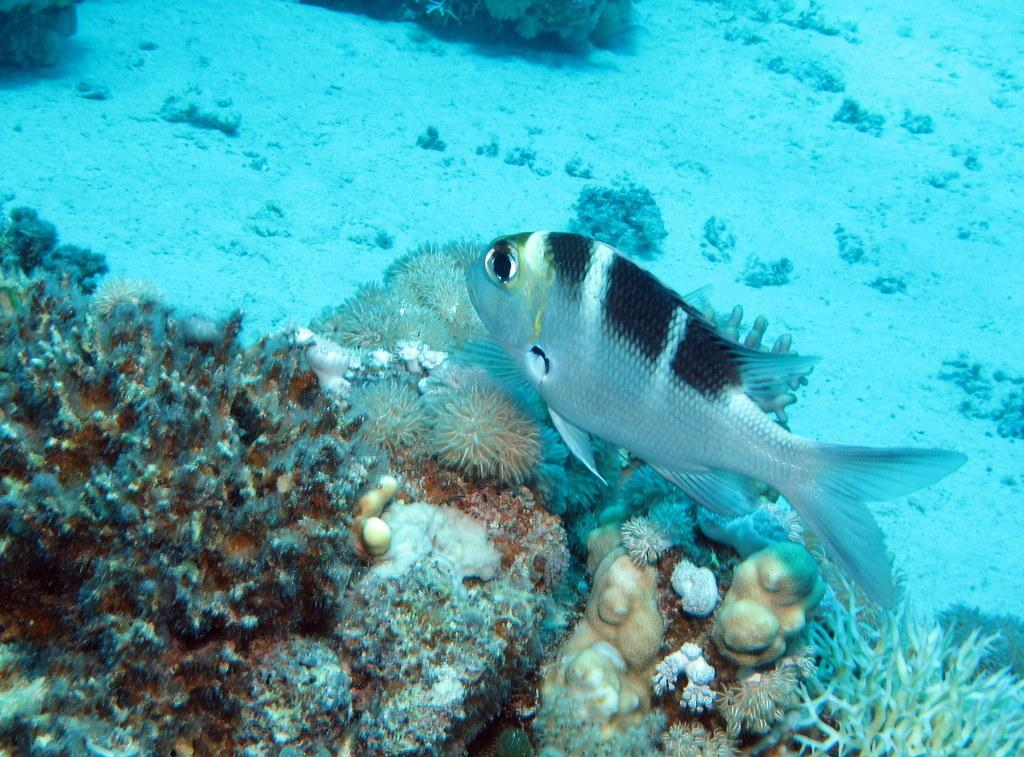What is the setting of the image? The image is taken underwater. What can be seen at the center of the image? There is a fish at the center of the image. Is there a badge visible on the fish in the image? There is no badge present on the fish in the image. Can you see a scarecrow in the underwater scene? There is no scarecrow present in the underwater scene; the image only features a fish. 